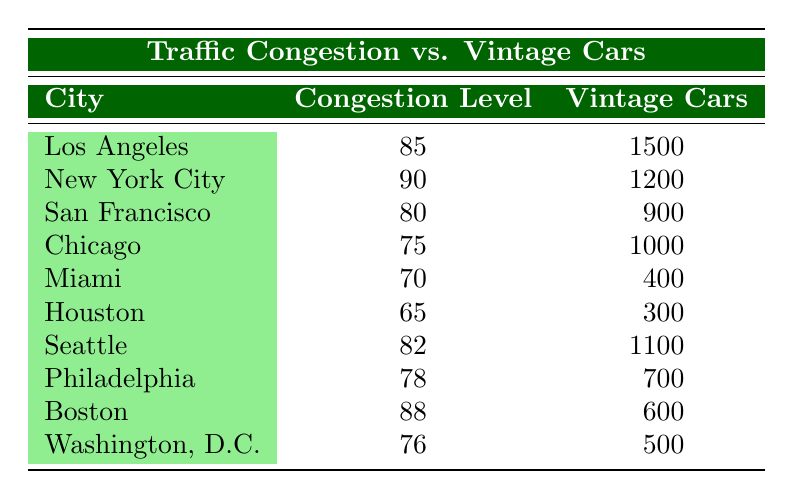What is the Traffic Congestion Level in Los Angeles? The table shows that the Traffic Congestion Level for Los Angeles is 85.
Answer: 85 How many Vintage Cars are there in New York City? Referring to the table, New York City has 1200 Vintage Cars.
Answer: 1200 What is the average number of Vintage Cars across all cities listed? To calculate the average, add the number of Vintage Cars: (1500 + 1200 + 900 + 1000 + 400 + 300 + 1100 + 700 + 600 + 500) = 6300. There are 10 cities, so the average is 6300 / 10 = 630.
Answer: 630 Is it true that Philadelphia has more Vintage Cars than Miami? According to the table, Philadelphia has 700 Vintage Cars, while Miami has 400, which means Philadelphia does have more Vintage Cars than Miami.
Answer: Yes Which city has the highest Traffic Congestion Level, and how many Vintage Cars does it have? The table indicates that New York City has the highest Traffic Congestion Level at 90, and it has 1200 Vintage Cars.
Answer: New York City, 1200 If you combine the number of Vintage Cars from Chicago and Boston, what is the sum? From the table, Chicago has 1000 Vintage Cars and Boston has 600. Adding these gives 1000 + 600 = 1600.
Answer: 1600 What is the difference in Traffic Congestion Levels between San Francisco and Seattle? The Traffic Congestion Level for San Francisco is 80 and for Seattle is 82. The difference is 82 - 80 = 2.
Answer: 2 Does Washington, D.C. have a Traffic Congestion Level lower than Miami? The table shows that Washington, D.C. has a Traffic Congestion Level of 76 while Miami has a level of 70; thus, Washington, D.C. does not have a lower level.
Answer: No What is the total Traffic Congestion Level for all cities mentioned? By summing the Traffic Congestion Levels: 85 + 90 + 80 + 75 + 70 + 65 + 82 + 78 + 88 + 76 = 80.8. Thus, the total is 80.8.
Answer: 80.8 